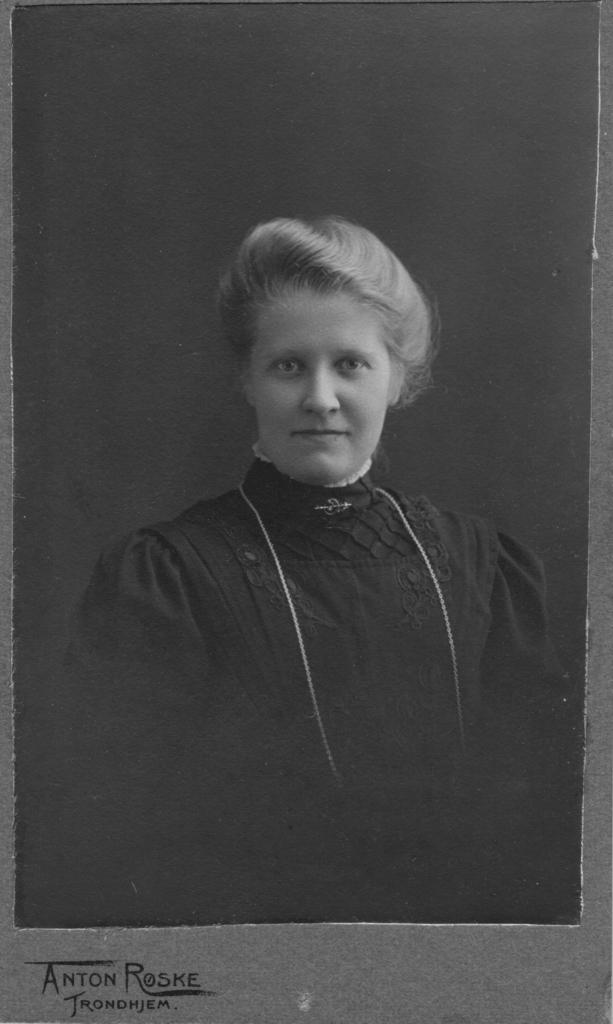What is the color scheme of the image? The image is black and white. Who or what is the main subject in the image? There is a woman in the image. Is there any text present in the image? Yes, there is text at the bottom of the image. What type of creature is hiding behind the curtain in the image? There is no creature or curtain present in the image. What medical advice is the doctor giving in the image? There is no doctor or medical advice present in the image. 